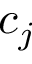<formula> <loc_0><loc_0><loc_500><loc_500>c _ { j }</formula> 